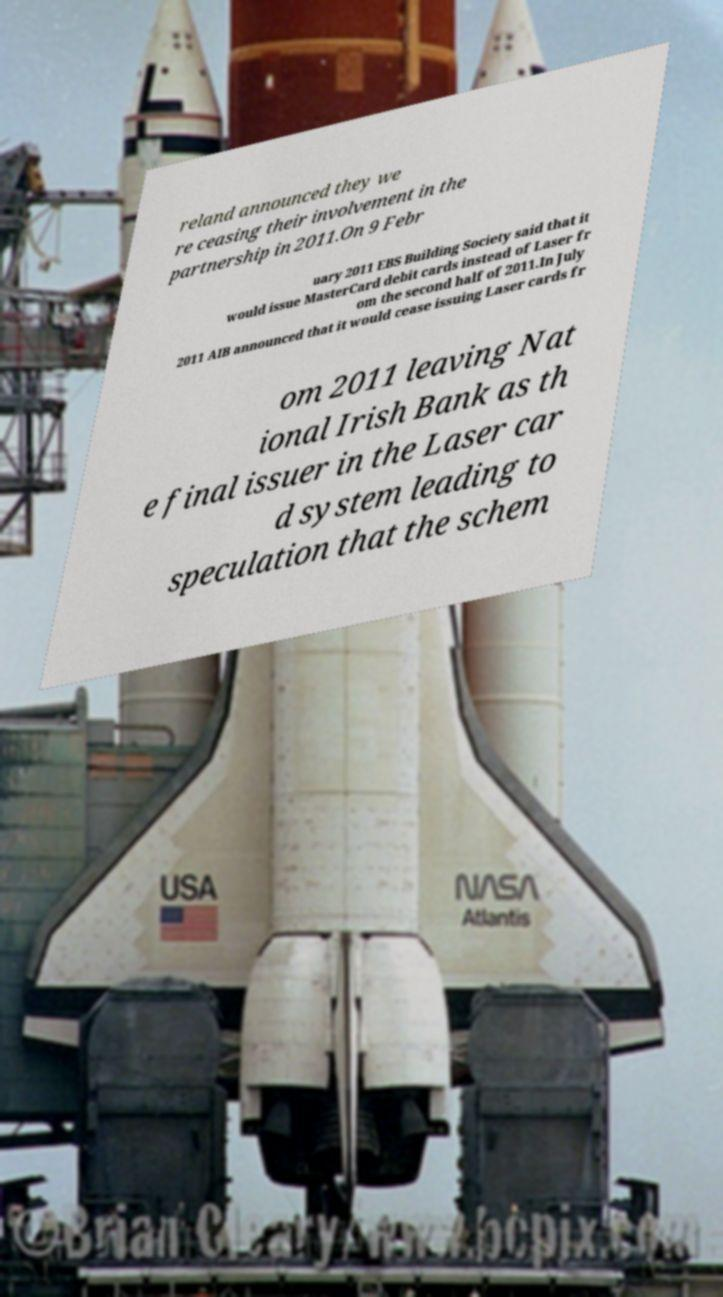Can you accurately transcribe the text from the provided image for me? reland announced they we re ceasing their involvement in the partnership in 2011.On 9 Febr uary 2011 EBS Building Society said that it would issue MasterCard debit cards instead of Laser fr om the second half of 2011.In July 2011 AIB announced that it would cease issuing Laser cards fr om 2011 leaving Nat ional Irish Bank as th e final issuer in the Laser car d system leading to speculation that the schem 